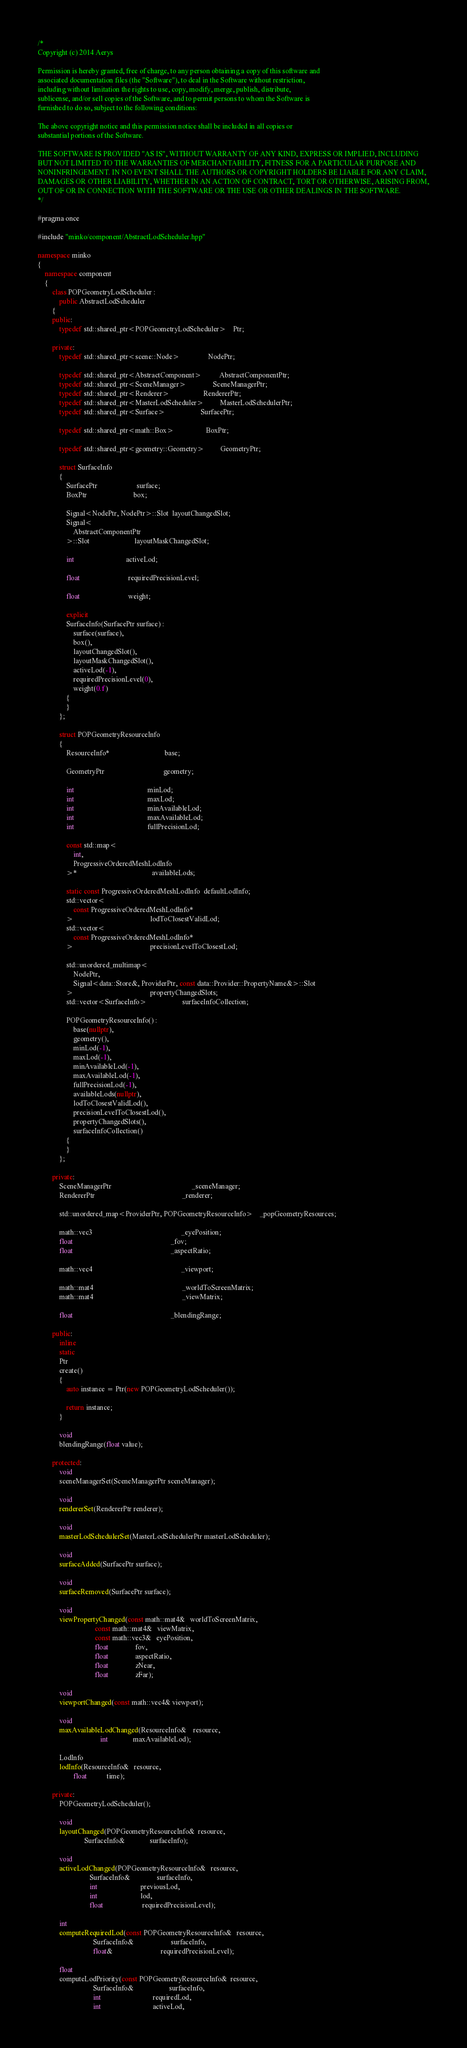<code> <loc_0><loc_0><loc_500><loc_500><_C++_>/*
Copyright (c) 2014 Aerys

Permission is hereby granted, free of charge, to any person obtaining a copy of this software and
associated documentation files (the "Software"), to deal in the Software without restriction,
including without limitation the rights to use, copy, modify, merge, publish, distribute,
sublicense, and/or sell copies of the Software, and to permit persons to whom the Software is
furnished to do so, subject to the following conditions:

The above copyright notice and this permission notice shall be included in all copies or
substantial portions of the Software.

THE SOFTWARE IS PROVIDED "AS IS", WITHOUT WARRANTY OF ANY KIND, EXPRESS OR IMPLIED, INCLUDING
BUT NOT LIMITED TO THE WARRANTIES OF MERCHANTABILITY, FITNESS FOR A PARTICULAR PURPOSE AND
NONINFRINGEMENT. IN NO EVENT SHALL THE AUTHORS OR COPYRIGHT HOLDERS BE LIABLE FOR ANY CLAIM,
DAMAGES OR OTHER LIABILITY, WHETHER IN AN ACTION OF CONTRACT, TORT OR OTHERWISE, ARISING FROM,
OUT OF OR IN CONNECTION WITH THE SOFTWARE OR THE USE OR OTHER DEALINGS IN THE SOFTWARE.
*/

#pragma once

#include "minko/component/AbstractLodScheduler.hpp"

namespace minko
{
	namespace component
	{
		class POPGeometryLodScheduler :
			public AbstractLodScheduler
		{
		public:
			typedef std::shared_ptr<POPGeometryLodScheduler>    Ptr;

        private:
            typedef std::shared_ptr<scene::Node>                NodePtr;
        
            typedef std::shared_ptr<AbstractComponent>          AbstractComponentPtr;
            typedef std::shared_ptr<SceneManager>               SceneManagerPtr;
            typedef std::shared_ptr<Renderer>                   RendererPtr;
            typedef std::shared_ptr<MasterLodScheduler>         MasterLodSchedulerPtr;
            typedef std::shared_ptr<Surface>                    SurfacePtr;

            typedef std::shared_ptr<math::Box>                  BoxPtr;

            typedef std::shared_ptr<geometry::Geometry>         GeometryPtr;

            struct SurfaceInfo
            {
                SurfacePtr                      surface;
                BoxPtr                          box;

                Signal<NodePtr, NodePtr>::Slot  layoutChangedSlot;
                Signal<
                    AbstractComponentPtr
                >::Slot                         layoutMaskChangedSlot;

                int                             activeLod;

                float                           requiredPrecisionLevel;

                float                           weight;

                explicit
                SurfaceInfo(SurfacePtr surface) :
                    surface(surface),
                    box(),
                    layoutChangedSlot(),
                    layoutMaskChangedSlot(),
                    activeLod(-1),
                    requiredPrecisionLevel(0),
                    weight(0.f)
                {
                }
            };

            struct POPGeometryResourceInfo
            {
                ResourceInfo*                               base;

                GeometryPtr                                 geometry;

                int                                         minLod;
                int                                         maxLod;
                int                                         minAvailableLod;
                int                                         maxAvailableLod;
                int                                         fullPrecisionLod;

                const std::map<
                    int,
                    ProgressiveOrderedMeshLodInfo
                >*                                          availableLods;

                static const ProgressiveOrderedMeshLodInfo  defaultLodInfo;
                std::vector<
                    const ProgressiveOrderedMeshLodInfo*
                >                                           lodToClosestValidLod;
                std::vector<
                    const ProgressiveOrderedMeshLodInfo*
                >                                           precisionLevelToClosestLod;

                std::unordered_multimap<
                    NodePtr,
                    Signal<data::Store&, ProviderPtr, const data::Provider::PropertyName&>::Slot
                >                                           propertyChangedSlots;
                std::vector<SurfaceInfo>                    surfaceInfoCollection;

                POPGeometryResourceInfo() :
                    base(nullptr),
                    geometry(),
                    minLod(-1),
                    maxLod(-1),
                    minAvailableLod(-1),
                    maxAvailableLod(-1),
                    fullPrecisionLod(-1),
                    availableLods(nullptr),
                    lodToClosestValidLod(),
                    precisionLevelToClosestLod(),
                    propertyChangedSlots(),
                    surfaceInfoCollection()
                {
                }
            };

        private:
            SceneManagerPtr                                             _sceneManager;
            RendererPtr                                                 _renderer;

            std::unordered_map<ProviderPtr, POPGeometryResourceInfo>    _popGeometryResources;

            math::vec3                                                  _eyePosition;
            float                                                       _fov;
            float                                                       _aspectRatio;

            math::vec4                                                  _viewport;

            math::mat4                                                  _worldToScreenMatrix;
            math::mat4                                                  _viewMatrix;

            float                                                       _blendingRange;

        public:
            inline
            static
            Ptr
            create()
            {
                auto instance = Ptr(new POPGeometryLodScheduler());

                return instance;
            }

            void
            blendingRange(float value);

        protected:
            void
            sceneManagerSet(SceneManagerPtr sceneManager);

            void
            rendererSet(RendererPtr renderer);

            void
            masterLodSchedulerSet(MasterLodSchedulerPtr masterLodScheduler);

            void
            surfaceAdded(SurfacePtr surface);

            void
            surfaceRemoved(SurfacePtr surface);

            void
            viewPropertyChanged(const math::mat4&   worldToScreenMatrix,
                                const math::mat4&   viewMatrix,
                                const math::vec3&   eyePosition,
                                float               fov,
                                float               aspectRatio,
                                float               zNear,
                                float               zFar);

            void
            viewportChanged(const math::vec4& viewport);

            void
            maxAvailableLodChanged(ResourceInfo&    resource,
                                   int              maxAvailableLod);

            LodInfo
            lodInfo(ResourceInfo&   resource,
                    float           time);

        private:
            POPGeometryLodScheduler();

            void
            layoutChanged(POPGeometryResourceInfo&  resource,
                          SurfaceInfo&              surfaceInfo);

            void
            activeLodChanged(POPGeometryResourceInfo&   resource,
                             SurfaceInfo&               surfaceInfo,
                             int                        previousLod,
                             int                        lod,
                             float                      requiredPrecisionLevel);

            int
            computeRequiredLod(const POPGeometryResourceInfo&   resource,
                               SurfaceInfo&                     surfaceInfo,
                               float&                           requiredPrecisionLevel);

            float
            computeLodPriority(const POPGeometryResourceInfo&  resource,
                               SurfaceInfo&                    surfaceInfo,
                               int                             requiredLod,
                               int                             activeLod,</code> 